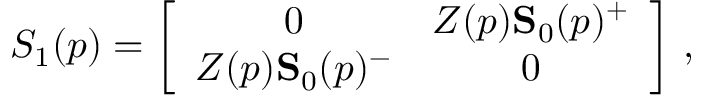<formula> <loc_0><loc_0><loc_500><loc_500>S _ { 1 } ( p ) = \left [ \begin{array} { c c } { 0 } & { { Z ( p ) { S } _ { 0 } ( p ) ^ { + } } } \\ { { Z ( p ) { S } _ { 0 } ( p ) ^ { - } } } & { 0 } \end{array} \right ] \, ,</formula> 